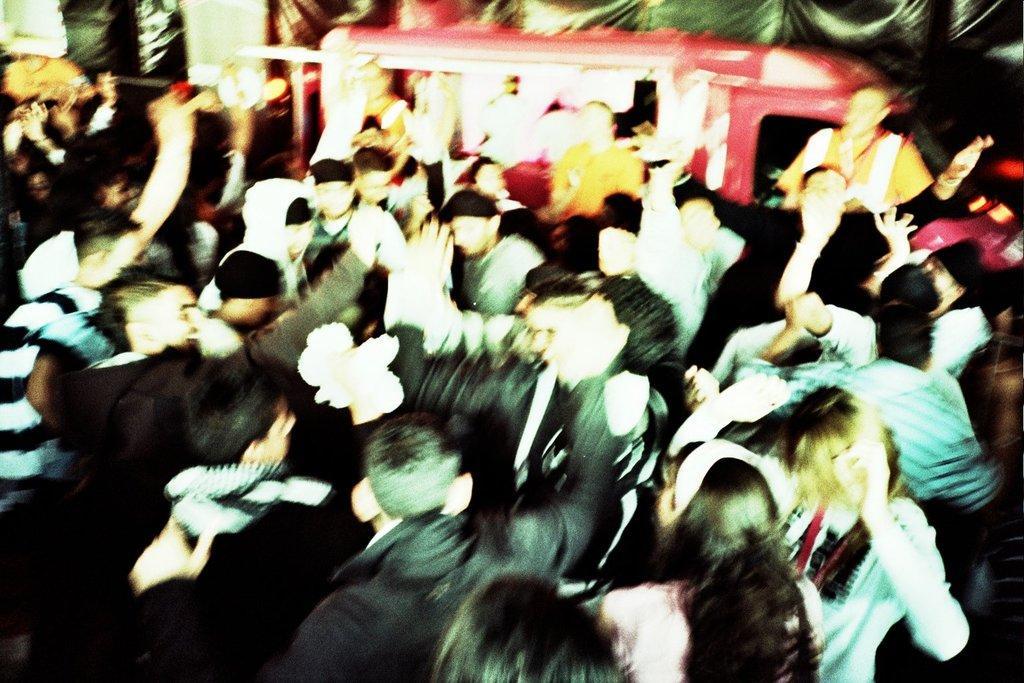Could you give a brief overview of what you see in this image? In this image we can see crowd. In the background there is a vehicle and we can see a curtain. 